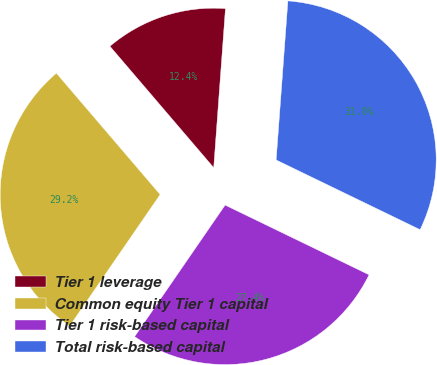<chart> <loc_0><loc_0><loc_500><loc_500><pie_chart><fcel>Tier 1 leverage<fcel>Common equity Tier 1 capital<fcel>Tier 1 risk-based capital<fcel>Total risk-based capital<nl><fcel>12.4%<fcel>29.2%<fcel>27.37%<fcel>31.03%<nl></chart> 